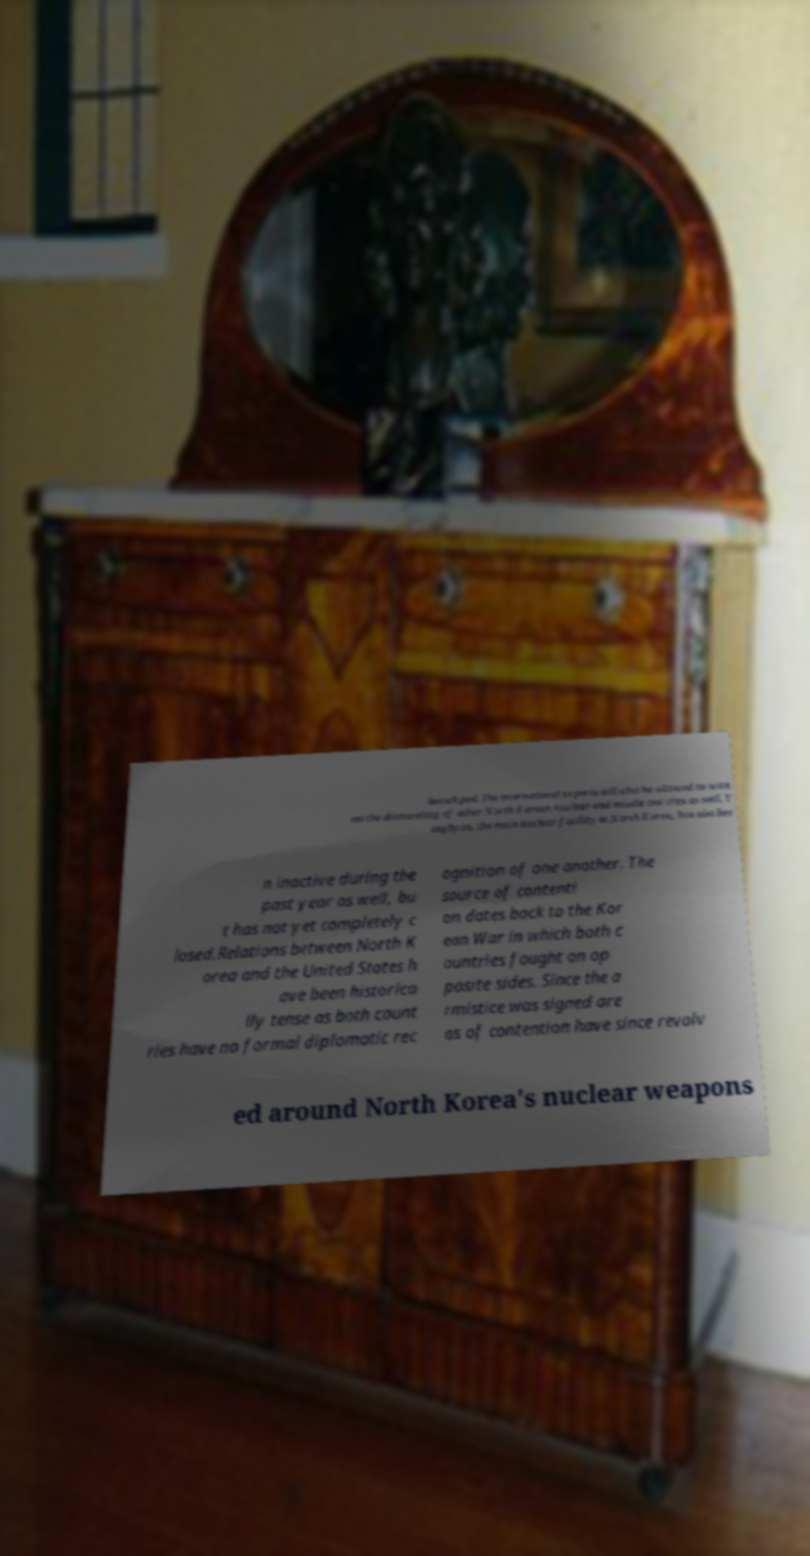Could you extract and type out the text from this image? launch pad. The international experts will also be allowed to witn ess the dismantling of other North Korean nuclear and missile test sites as well. Y ongbyon, the main nuclear facility in North Korea, has also bee n inactive during the past year as well, bu t has not yet completely c losed.Relations between North K orea and the United States h ave been historica lly tense as both count ries have no formal diplomatic rec ognition of one another. The source of contenti on dates back to the Kor ean War in which both c ountries fought on op posite sides. Since the a rmistice was signed are as of contention have since revolv ed around North Korea's nuclear weapons 